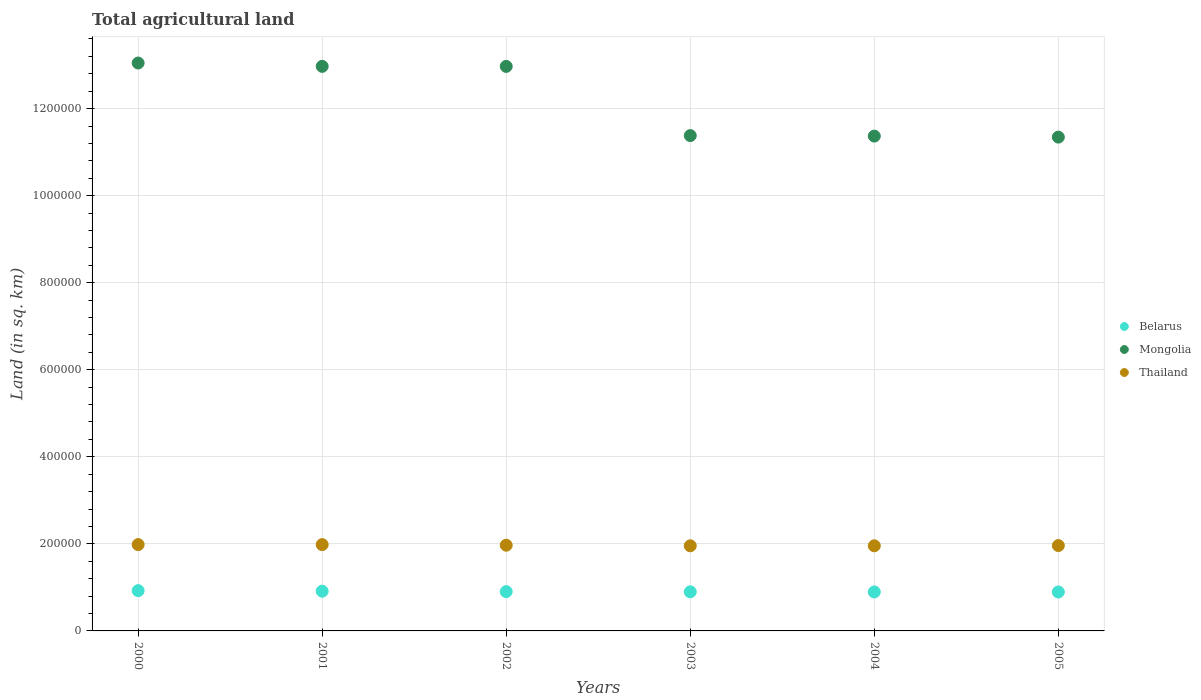How many different coloured dotlines are there?
Your response must be concise. 3. Is the number of dotlines equal to the number of legend labels?
Your response must be concise. Yes. What is the total agricultural land in Belarus in 2003?
Ensure brevity in your answer.  8.99e+04. Across all years, what is the maximum total agricultural land in Belarus?
Your response must be concise. 9.25e+04. Across all years, what is the minimum total agricultural land in Mongolia?
Make the answer very short. 1.13e+06. In which year was the total agricultural land in Thailand maximum?
Give a very brief answer. 2000. In which year was the total agricultural land in Mongolia minimum?
Keep it short and to the point. 2005. What is the total total agricultural land in Mongolia in the graph?
Offer a terse response. 7.31e+06. What is the difference between the total agricultural land in Belarus in 2003 and that in 2005?
Offer a very short reply. 370. What is the difference between the total agricultural land in Belarus in 2004 and the total agricultural land in Mongolia in 2003?
Your answer should be very brief. -1.05e+06. What is the average total agricultural land in Mongolia per year?
Provide a short and direct response. 1.22e+06. In the year 2000, what is the difference between the total agricultural land in Belarus and total agricultural land in Thailand?
Provide a short and direct response. -1.06e+05. In how many years, is the total agricultural land in Belarus greater than 1080000 sq.km?
Offer a terse response. 0. What is the ratio of the total agricultural land in Mongolia in 2000 to that in 2005?
Provide a short and direct response. 1.15. Is the total agricultural land in Thailand in 2003 less than that in 2004?
Keep it short and to the point. Yes. Is the difference between the total agricultural land in Belarus in 2001 and 2005 greater than the difference between the total agricultural land in Thailand in 2001 and 2005?
Provide a succinct answer. No. What is the difference between the highest and the second highest total agricultural land in Belarus?
Your response must be concise. 1240. What is the difference between the highest and the lowest total agricultural land in Thailand?
Ensure brevity in your answer.  2800. Is it the case that in every year, the sum of the total agricultural land in Mongolia and total agricultural land in Thailand  is greater than the total agricultural land in Belarus?
Offer a terse response. Yes. Does the total agricultural land in Mongolia monotonically increase over the years?
Your answer should be compact. No. Is the total agricultural land in Mongolia strictly greater than the total agricultural land in Thailand over the years?
Provide a succinct answer. Yes. Is the total agricultural land in Mongolia strictly less than the total agricultural land in Belarus over the years?
Offer a very short reply. No. How many years are there in the graph?
Offer a very short reply. 6. Does the graph contain grids?
Offer a terse response. Yes. How many legend labels are there?
Keep it short and to the point. 3. What is the title of the graph?
Your response must be concise. Total agricultural land. Does "Trinidad and Tobago" appear as one of the legend labels in the graph?
Give a very brief answer. No. What is the label or title of the X-axis?
Make the answer very short. Years. What is the label or title of the Y-axis?
Keep it short and to the point. Land (in sq. km). What is the Land (in sq. km) in Belarus in 2000?
Provide a short and direct response. 9.25e+04. What is the Land (in sq. km) of Mongolia in 2000?
Ensure brevity in your answer.  1.30e+06. What is the Land (in sq. km) in Thailand in 2000?
Your answer should be very brief. 1.98e+05. What is the Land (in sq. km) in Belarus in 2001?
Ensure brevity in your answer.  9.13e+04. What is the Land (in sq. km) in Mongolia in 2001?
Provide a short and direct response. 1.30e+06. What is the Land (in sq. km) of Thailand in 2001?
Offer a terse response. 1.98e+05. What is the Land (in sq. km) of Belarus in 2002?
Offer a terse response. 9.02e+04. What is the Land (in sq. km) in Mongolia in 2002?
Make the answer very short. 1.30e+06. What is the Land (in sq. km) of Thailand in 2002?
Offer a very short reply. 1.97e+05. What is the Land (in sq. km) of Belarus in 2003?
Keep it short and to the point. 8.99e+04. What is the Land (in sq. km) of Mongolia in 2003?
Your response must be concise. 1.14e+06. What is the Land (in sq. km) in Thailand in 2003?
Ensure brevity in your answer.  1.96e+05. What is the Land (in sq. km) in Belarus in 2004?
Offer a very short reply. 8.96e+04. What is the Land (in sq. km) in Mongolia in 2004?
Make the answer very short. 1.14e+06. What is the Land (in sq. km) of Thailand in 2004?
Your answer should be very brief. 1.96e+05. What is the Land (in sq. km) of Belarus in 2005?
Make the answer very short. 8.95e+04. What is the Land (in sq. km) in Mongolia in 2005?
Keep it short and to the point. 1.13e+06. What is the Land (in sq. km) in Thailand in 2005?
Your answer should be very brief. 1.96e+05. Across all years, what is the maximum Land (in sq. km) in Belarus?
Provide a succinct answer. 9.25e+04. Across all years, what is the maximum Land (in sq. km) in Mongolia?
Ensure brevity in your answer.  1.30e+06. Across all years, what is the maximum Land (in sq. km) of Thailand?
Give a very brief answer. 1.98e+05. Across all years, what is the minimum Land (in sq. km) of Belarus?
Provide a short and direct response. 8.95e+04. Across all years, what is the minimum Land (in sq. km) of Mongolia?
Your answer should be very brief. 1.13e+06. Across all years, what is the minimum Land (in sq. km) of Thailand?
Provide a succinct answer. 1.96e+05. What is the total Land (in sq. km) of Belarus in the graph?
Provide a succinct answer. 5.43e+05. What is the total Land (in sq. km) of Mongolia in the graph?
Give a very brief answer. 7.31e+06. What is the total Land (in sq. km) of Thailand in the graph?
Ensure brevity in your answer.  1.18e+06. What is the difference between the Land (in sq. km) in Belarus in 2000 and that in 2001?
Offer a terse response. 1240. What is the difference between the Land (in sq. km) in Mongolia in 2000 and that in 2001?
Your answer should be very brief. 7660. What is the difference between the Land (in sq. km) of Thailand in 2000 and that in 2001?
Keep it short and to the point. 60. What is the difference between the Land (in sq. km) of Belarus in 2000 and that in 2002?
Provide a short and direct response. 2270. What is the difference between the Land (in sq. km) of Mongolia in 2000 and that in 2002?
Ensure brevity in your answer.  7750. What is the difference between the Land (in sq. km) of Thailand in 2000 and that in 2002?
Offer a terse response. 1450. What is the difference between the Land (in sq. km) in Belarus in 2000 and that in 2003?
Provide a succinct answer. 2660. What is the difference between the Land (in sq. km) in Mongolia in 2000 and that in 2003?
Give a very brief answer. 1.67e+05. What is the difference between the Land (in sq. km) of Thailand in 2000 and that in 2003?
Provide a short and direct response. 2800. What is the difference between the Land (in sq. km) in Belarus in 2000 and that in 2004?
Keep it short and to the point. 2950. What is the difference between the Land (in sq. km) in Mongolia in 2000 and that in 2004?
Give a very brief answer. 1.68e+05. What is the difference between the Land (in sq. km) of Thailand in 2000 and that in 2004?
Your answer should be very brief. 2790. What is the difference between the Land (in sq. km) of Belarus in 2000 and that in 2005?
Ensure brevity in your answer.  3030. What is the difference between the Land (in sq. km) of Mongolia in 2000 and that in 2005?
Offer a very short reply. 1.70e+05. What is the difference between the Land (in sq. km) of Thailand in 2000 and that in 2005?
Your answer should be very brief. 2240. What is the difference between the Land (in sq. km) of Belarus in 2001 and that in 2002?
Your answer should be compact. 1030. What is the difference between the Land (in sq. km) of Thailand in 2001 and that in 2002?
Offer a very short reply. 1390. What is the difference between the Land (in sq. km) of Belarus in 2001 and that in 2003?
Provide a succinct answer. 1420. What is the difference between the Land (in sq. km) of Mongolia in 2001 and that in 2003?
Your response must be concise. 1.59e+05. What is the difference between the Land (in sq. km) of Thailand in 2001 and that in 2003?
Keep it short and to the point. 2740. What is the difference between the Land (in sq. km) of Belarus in 2001 and that in 2004?
Your answer should be very brief. 1710. What is the difference between the Land (in sq. km) of Mongolia in 2001 and that in 2004?
Provide a short and direct response. 1.60e+05. What is the difference between the Land (in sq. km) in Thailand in 2001 and that in 2004?
Your answer should be compact. 2730. What is the difference between the Land (in sq. km) of Belarus in 2001 and that in 2005?
Make the answer very short. 1790. What is the difference between the Land (in sq. km) of Mongolia in 2001 and that in 2005?
Provide a succinct answer. 1.63e+05. What is the difference between the Land (in sq. km) of Thailand in 2001 and that in 2005?
Provide a succinct answer. 2180. What is the difference between the Land (in sq. km) in Belarus in 2002 and that in 2003?
Your response must be concise. 390. What is the difference between the Land (in sq. km) of Mongolia in 2002 and that in 2003?
Your answer should be compact. 1.59e+05. What is the difference between the Land (in sq. km) of Thailand in 2002 and that in 2003?
Your answer should be very brief. 1350. What is the difference between the Land (in sq. km) in Belarus in 2002 and that in 2004?
Ensure brevity in your answer.  680. What is the difference between the Land (in sq. km) of Mongolia in 2002 and that in 2004?
Offer a terse response. 1.60e+05. What is the difference between the Land (in sq. km) of Thailand in 2002 and that in 2004?
Make the answer very short. 1340. What is the difference between the Land (in sq. km) of Belarus in 2002 and that in 2005?
Offer a terse response. 760. What is the difference between the Land (in sq. km) in Mongolia in 2002 and that in 2005?
Keep it short and to the point. 1.62e+05. What is the difference between the Land (in sq. km) in Thailand in 2002 and that in 2005?
Give a very brief answer. 790. What is the difference between the Land (in sq. km) of Belarus in 2003 and that in 2004?
Provide a succinct answer. 290. What is the difference between the Land (in sq. km) of Mongolia in 2003 and that in 2004?
Provide a succinct answer. 1142. What is the difference between the Land (in sq. km) of Belarus in 2003 and that in 2005?
Provide a succinct answer. 370. What is the difference between the Land (in sq. km) of Mongolia in 2003 and that in 2005?
Your answer should be very brief. 3466. What is the difference between the Land (in sq. km) of Thailand in 2003 and that in 2005?
Keep it short and to the point. -560. What is the difference between the Land (in sq. km) of Mongolia in 2004 and that in 2005?
Give a very brief answer. 2324. What is the difference between the Land (in sq. km) of Thailand in 2004 and that in 2005?
Your response must be concise. -550. What is the difference between the Land (in sq. km) of Belarus in 2000 and the Land (in sq. km) of Mongolia in 2001?
Your response must be concise. -1.20e+06. What is the difference between the Land (in sq. km) in Belarus in 2000 and the Land (in sq. km) in Thailand in 2001?
Your answer should be very brief. -1.06e+05. What is the difference between the Land (in sq. km) of Mongolia in 2000 and the Land (in sq. km) of Thailand in 2001?
Keep it short and to the point. 1.11e+06. What is the difference between the Land (in sq. km) in Belarus in 2000 and the Land (in sq. km) in Mongolia in 2002?
Your answer should be compact. -1.20e+06. What is the difference between the Land (in sq. km) of Belarus in 2000 and the Land (in sq. km) of Thailand in 2002?
Your answer should be very brief. -1.04e+05. What is the difference between the Land (in sq. km) in Mongolia in 2000 and the Land (in sq. km) in Thailand in 2002?
Give a very brief answer. 1.11e+06. What is the difference between the Land (in sq. km) in Belarus in 2000 and the Land (in sq. km) in Mongolia in 2003?
Give a very brief answer. -1.05e+06. What is the difference between the Land (in sq. km) of Belarus in 2000 and the Land (in sq. km) of Thailand in 2003?
Offer a very short reply. -1.03e+05. What is the difference between the Land (in sq. km) in Mongolia in 2000 and the Land (in sq. km) in Thailand in 2003?
Offer a terse response. 1.11e+06. What is the difference between the Land (in sq. km) of Belarus in 2000 and the Land (in sq. km) of Mongolia in 2004?
Provide a short and direct response. -1.04e+06. What is the difference between the Land (in sq. km) in Belarus in 2000 and the Land (in sq. km) in Thailand in 2004?
Your answer should be compact. -1.03e+05. What is the difference between the Land (in sq. km) of Mongolia in 2000 and the Land (in sq. km) of Thailand in 2004?
Give a very brief answer. 1.11e+06. What is the difference between the Land (in sq. km) of Belarus in 2000 and the Land (in sq. km) of Mongolia in 2005?
Your answer should be very brief. -1.04e+06. What is the difference between the Land (in sq. km) of Belarus in 2000 and the Land (in sq. km) of Thailand in 2005?
Give a very brief answer. -1.04e+05. What is the difference between the Land (in sq. km) in Mongolia in 2000 and the Land (in sq. km) in Thailand in 2005?
Provide a short and direct response. 1.11e+06. What is the difference between the Land (in sq. km) in Belarus in 2001 and the Land (in sq. km) in Mongolia in 2002?
Your response must be concise. -1.21e+06. What is the difference between the Land (in sq. km) in Belarus in 2001 and the Land (in sq. km) in Thailand in 2002?
Ensure brevity in your answer.  -1.06e+05. What is the difference between the Land (in sq. km) of Mongolia in 2001 and the Land (in sq. km) of Thailand in 2002?
Your response must be concise. 1.10e+06. What is the difference between the Land (in sq. km) of Belarus in 2001 and the Land (in sq. km) of Mongolia in 2003?
Offer a very short reply. -1.05e+06. What is the difference between the Land (in sq. km) in Belarus in 2001 and the Land (in sq. km) in Thailand in 2003?
Your response must be concise. -1.04e+05. What is the difference between the Land (in sq. km) in Mongolia in 2001 and the Land (in sq. km) in Thailand in 2003?
Offer a very short reply. 1.10e+06. What is the difference between the Land (in sq. km) of Belarus in 2001 and the Land (in sq. km) of Mongolia in 2004?
Offer a terse response. -1.05e+06. What is the difference between the Land (in sq. km) in Belarus in 2001 and the Land (in sq. km) in Thailand in 2004?
Ensure brevity in your answer.  -1.04e+05. What is the difference between the Land (in sq. km) in Mongolia in 2001 and the Land (in sq. km) in Thailand in 2004?
Keep it short and to the point. 1.10e+06. What is the difference between the Land (in sq. km) of Belarus in 2001 and the Land (in sq. km) of Mongolia in 2005?
Make the answer very short. -1.04e+06. What is the difference between the Land (in sq. km) in Belarus in 2001 and the Land (in sq. km) in Thailand in 2005?
Give a very brief answer. -1.05e+05. What is the difference between the Land (in sq. km) of Mongolia in 2001 and the Land (in sq. km) of Thailand in 2005?
Keep it short and to the point. 1.10e+06. What is the difference between the Land (in sq. km) in Belarus in 2002 and the Land (in sq. km) in Mongolia in 2003?
Make the answer very short. -1.05e+06. What is the difference between the Land (in sq. km) in Belarus in 2002 and the Land (in sq. km) in Thailand in 2003?
Your answer should be compact. -1.05e+05. What is the difference between the Land (in sq. km) of Mongolia in 2002 and the Land (in sq. km) of Thailand in 2003?
Ensure brevity in your answer.  1.10e+06. What is the difference between the Land (in sq. km) in Belarus in 2002 and the Land (in sq. km) in Mongolia in 2004?
Your answer should be very brief. -1.05e+06. What is the difference between the Land (in sq. km) of Belarus in 2002 and the Land (in sq. km) of Thailand in 2004?
Make the answer very short. -1.05e+05. What is the difference between the Land (in sq. km) in Mongolia in 2002 and the Land (in sq. km) in Thailand in 2004?
Make the answer very short. 1.10e+06. What is the difference between the Land (in sq. km) in Belarus in 2002 and the Land (in sq. km) in Mongolia in 2005?
Provide a short and direct response. -1.04e+06. What is the difference between the Land (in sq. km) in Belarus in 2002 and the Land (in sq. km) in Thailand in 2005?
Your response must be concise. -1.06e+05. What is the difference between the Land (in sq. km) of Mongolia in 2002 and the Land (in sq. km) of Thailand in 2005?
Provide a succinct answer. 1.10e+06. What is the difference between the Land (in sq. km) of Belarus in 2003 and the Land (in sq. km) of Mongolia in 2004?
Keep it short and to the point. -1.05e+06. What is the difference between the Land (in sq. km) of Belarus in 2003 and the Land (in sq. km) of Thailand in 2004?
Offer a very short reply. -1.06e+05. What is the difference between the Land (in sq. km) of Mongolia in 2003 and the Land (in sq. km) of Thailand in 2004?
Offer a terse response. 9.42e+05. What is the difference between the Land (in sq. km) of Belarus in 2003 and the Land (in sq. km) of Mongolia in 2005?
Ensure brevity in your answer.  -1.04e+06. What is the difference between the Land (in sq. km) in Belarus in 2003 and the Land (in sq. km) in Thailand in 2005?
Provide a short and direct response. -1.06e+05. What is the difference between the Land (in sq. km) of Mongolia in 2003 and the Land (in sq. km) of Thailand in 2005?
Offer a very short reply. 9.42e+05. What is the difference between the Land (in sq. km) in Belarus in 2004 and the Land (in sq. km) in Mongolia in 2005?
Make the answer very short. -1.04e+06. What is the difference between the Land (in sq. km) in Belarus in 2004 and the Land (in sq. km) in Thailand in 2005?
Provide a succinct answer. -1.07e+05. What is the difference between the Land (in sq. km) of Mongolia in 2004 and the Land (in sq. km) of Thailand in 2005?
Your response must be concise. 9.41e+05. What is the average Land (in sq. km) of Belarus per year?
Provide a short and direct response. 9.05e+04. What is the average Land (in sq. km) in Mongolia per year?
Provide a succinct answer. 1.22e+06. What is the average Land (in sq. km) in Thailand per year?
Provide a short and direct response. 1.97e+05. In the year 2000, what is the difference between the Land (in sq. km) of Belarus and Land (in sq. km) of Mongolia?
Offer a very short reply. -1.21e+06. In the year 2000, what is the difference between the Land (in sq. km) of Belarus and Land (in sq. km) of Thailand?
Your answer should be compact. -1.06e+05. In the year 2000, what is the difference between the Land (in sq. km) of Mongolia and Land (in sq. km) of Thailand?
Your answer should be very brief. 1.11e+06. In the year 2001, what is the difference between the Land (in sq. km) in Belarus and Land (in sq. km) in Mongolia?
Your response must be concise. -1.21e+06. In the year 2001, what is the difference between the Land (in sq. km) of Belarus and Land (in sq. km) of Thailand?
Provide a succinct answer. -1.07e+05. In the year 2001, what is the difference between the Land (in sq. km) in Mongolia and Land (in sq. km) in Thailand?
Offer a very short reply. 1.10e+06. In the year 2002, what is the difference between the Land (in sq. km) of Belarus and Land (in sq. km) of Mongolia?
Give a very brief answer. -1.21e+06. In the year 2002, what is the difference between the Land (in sq. km) of Belarus and Land (in sq. km) of Thailand?
Offer a terse response. -1.07e+05. In the year 2002, what is the difference between the Land (in sq. km) of Mongolia and Land (in sq. km) of Thailand?
Make the answer very short. 1.10e+06. In the year 2003, what is the difference between the Land (in sq. km) in Belarus and Land (in sq. km) in Mongolia?
Ensure brevity in your answer.  -1.05e+06. In the year 2003, what is the difference between the Land (in sq. km) of Belarus and Land (in sq. km) of Thailand?
Your answer should be compact. -1.06e+05. In the year 2003, what is the difference between the Land (in sq. km) in Mongolia and Land (in sq. km) in Thailand?
Ensure brevity in your answer.  9.42e+05. In the year 2004, what is the difference between the Land (in sq. km) in Belarus and Land (in sq. km) in Mongolia?
Provide a succinct answer. -1.05e+06. In the year 2004, what is the difference between the Land (in sq. km) in Belarus and Land (in sq. km) in Thailand?
Provide a succinct answer. -1.06e+05. In the year 2004, what is the difference between the Land (in sq. km) in Mongolia and Land (in sq. km) in Thailand?
Provide a short and direct response. 9.41e+05. In the year 2005, what is the difference between the Land (in sq. km) in Belarus and Land (in sq. km) in Mongolia?
Provide a short and direct response. -1.05e+06. In the year 2005, what is the difference between the Land (in sq. km) of Belarus and Land (in sq. km) of Thailand?
Provide a short and direct response. -1.07e+05. In the year 2005, what is the difference between the Land (in sq. km) in Mongolia and Land (in sq. km) in Thailand?
Offer a terse response. 9.38e+05. What is the ratio of the Land (in sq. km) in Belarus in 2000 to that in 2001?
Give a very brief answer. 1.01. What is the ratio of the Land (in sq. km) of Mongolia in 2000 to that in 2001?
Provide a short and direct response. 1.01. What is the ratio of the Land (in sq. km) in Belarus in 2000 to that in 2002?
Ensure brevity in your answer.  1.03. What is the ratio of the Land (in sq. km) of Thailand in 2000 to that in 2002?
Your answer should be very brief. 1.01. What is the ratio of the Land (in sq. km) in Belarus in 2000 to that in 2003?
Give a very brief answer. 1.03. What is the ratio of the Land (in sq. km) of Mongolia in 2000 to that in 2003?
Give a very brief answer. 1.15. What is the ratio of the Land (in sq. km) in Thailand in 2000 to that in 2003?
Your response must be concise. 1.01. What is the ratio of the Land (in sq. km) in Belarus in 2000 to that in 2004?
Offer a very short reply. 1.03. What is the ratio of the Land (in sq. km) of Mongolia in 2000 to that in 2004?
Your answer should be compact. 1.15. What is the ratio of the Land (in sq. km) in Thailand in 2000 to that in 2004?
Your response must be concise. 1.01. What is the ratio of the Land (in sq. km) of Belarus in 2000 to that in 2005?
Provide a short and direct response. 1.03. What is the ratio of the Land (in sq. km) of Mongolia in 2000 to that in 2005?
Give a very brief answer. 1.15. What is the ratio of the Land (in sq. km) of Thailand in 2000 to that in 2005?
Make the answer very short. 1.01. What is the ratio of the Land (in sq. km) in Belarus in 2001 to that in 2002?
Give a very brief answer. 1.01. What is the ratio of the Land (in sq. km) in Thailand in 2001 to that in 2002?
Ensure brevity in your answer.  1.01. What is the ratio of the Land (in sq. km) of Belarus in 2001 to that in 2003?
Your answer should be compact. 1.02. What is the ratio of the Land (in sq. km) of Mongolia in 2001 to that in 2003?
Offer a terse response. 1.14. What is the ratio of the Land (in sq. km) in Belarus in 2001 to that in 2004?
Keep it short and to the point. 1.02. What is the ratio of the Land (in sq. km) in Mongolia in 2001 to that in 2004?
Offer a terse response. 1.14. What is the ratio of the Land (in sq. km) of Mongolia in 2001 to that in 2005?
Your answer should be compact. 1.14. What is the ratio of the Land (in sq. km) in Thailand in 2001 to that in 2005?
Your answer should be compact. 1.01. What is the ratio of the Land (in sq. km) of Belarus in 2002 to that in 2003?
Your response must be concise. 1. What is the ratio of the Land (in sq. km) of Mongolia in 2002 to that in 2003?
Make the answer very short. 1.14. What is the ratio of the Land (in sq. km) of Thailand in 2002 to that in 2003?
Make the answer very short. 1.01. What is the ratio of the Land (in sq. km) in Belarus in 2002 to that in 2004?
Provide a short and direct response. 1.01. What is the ratio of the Land (in sq. km) in Mongolia in 2002 to that in 2004?
Keep it short and to the point. 1.14. What is the ratio of the Land (in sq. km) in Thailand in 2002 to that in 2004?
Keep it short and to the point. 1.01. What is the ratio of the Land (in sq. km) of Belarus in 2002 to that in 2005?
Keep it short and to the point. 1.01. What is the ratio of the Land (in sq. km) of Mongolia in 2002 to that in 2005?
Offer a terse response. 1.14. What is the ratio of the Land (in sq. km) of Thailand in 2002 to that in 2005?
Make the answer very short. 1. What is the ratio of the Land (in sq. km) in Mongolia in 2003 to that in 2004?
Your response must be concise. 1. What is the ratio of the Land (in sq. km) in Belarus in 2003 to that in 2005?
Give a very brief answer. 1. What is the ratio of the Land (in sq. km) of Mongolia in 2003 to that in 2005?
Your answer should be compact. 1. What is the ratio of the Land (in sq. km) of Mongolia in 2004 to that in 2005?
Give a very brief answer. 1. What is the ratio of the Land (in sq. km) in Thailand in 2004 to that in 2005?
Offer a terse response. 1. What is the difference between the highest and the second highest Land (in sq. km) in Belarus?
Provide a short and direct response. 1240. What is the difference between the highest and the second highest Land (in sq. km) of Mongolia?
Your response must be concise. 7660. What is the difference between the highest and the second highest Land (in sq. km) of Thailand?
Your answer should be very brief. 60. What is the difference between the highest and the lowest Land (in sq. km) in Belarus?
Provide a short and direct response. 3030. What is the difference between the highest and the lowest Land (in sq. km) of Mongolia?
Offer a terse response. 1.70e+05. What is the difference between the highest and the lowest Land (in sq. km) in Thailand?
Provide a short and direct response. 2800. 